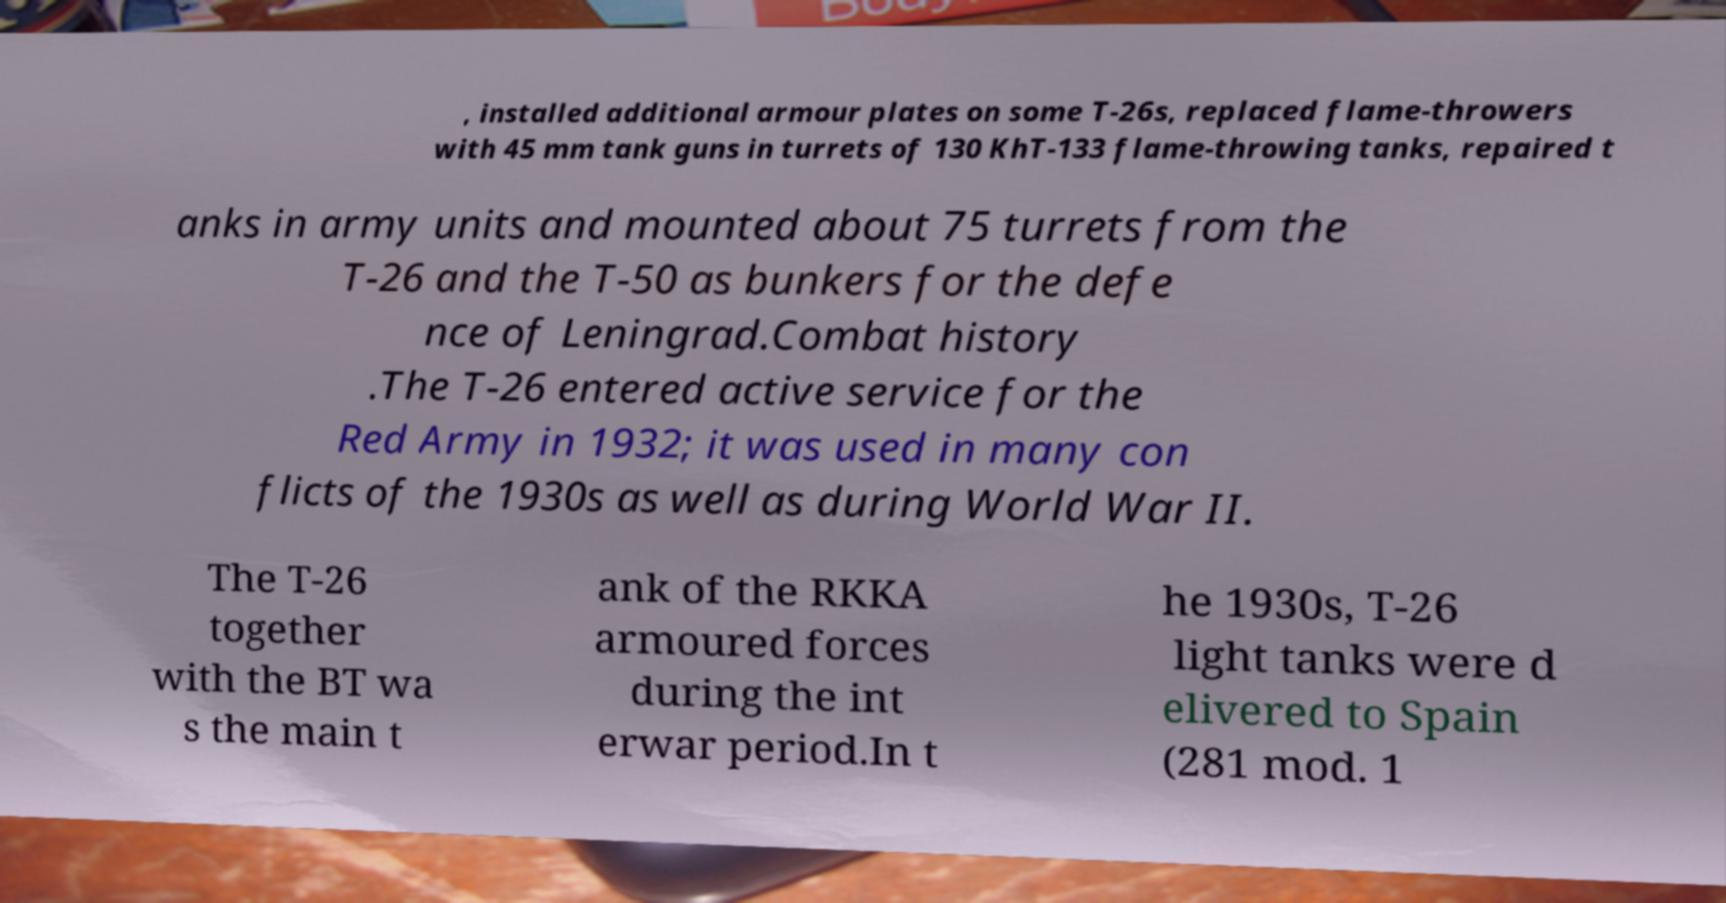Please read and relay the text visible in this image. What does it say? , installed additional armour plates on some T-26s, replaced flame-throwers with 45 mm tank guns in turrets of 130 KhT-133 flame-throwing tanks, repaired t anks in army units and mounted about 75 turrets from the T-26 and the T-50 as bunkers for the defe nce of Leningrad.Combat history .The T-26 entered active service for the Red Army in 1932; it was used in many con flicts of the 1930s as well as during World War II. The T-26 together with the BT wa s the main t ank of the RKKA armoured forces during the int erwar period.In t he 1930s, T-26 light tanks were d elivered to Spain (281 mod. 1 